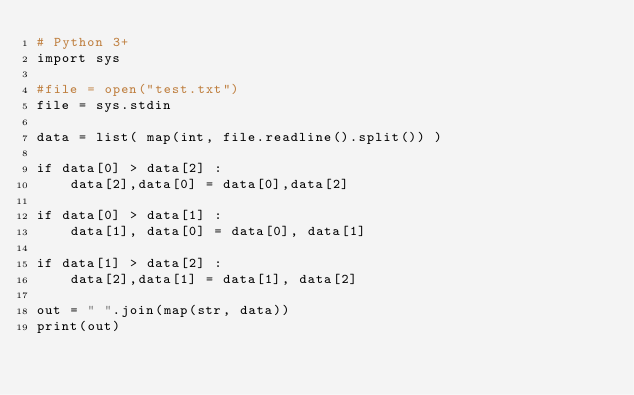Convert code to text. <code><loc_0><loc_0><loc_500><loc_500><_Python_># Python 3+
import sys

#file = open("test.txt")
file = sys.stdin

data = list( map(int, file.readline().split()) )

if data[0] > data[2] :
    data[2],data[0] = data[0],data[2]

if data[0] > data[1] :
    data[1], data[0] = data[0], data[1]

if data[1] > data[2] :
    data[2],data[1] = data[1], data[2]

out = " ".join(map(str, data))
print(out)</code> 